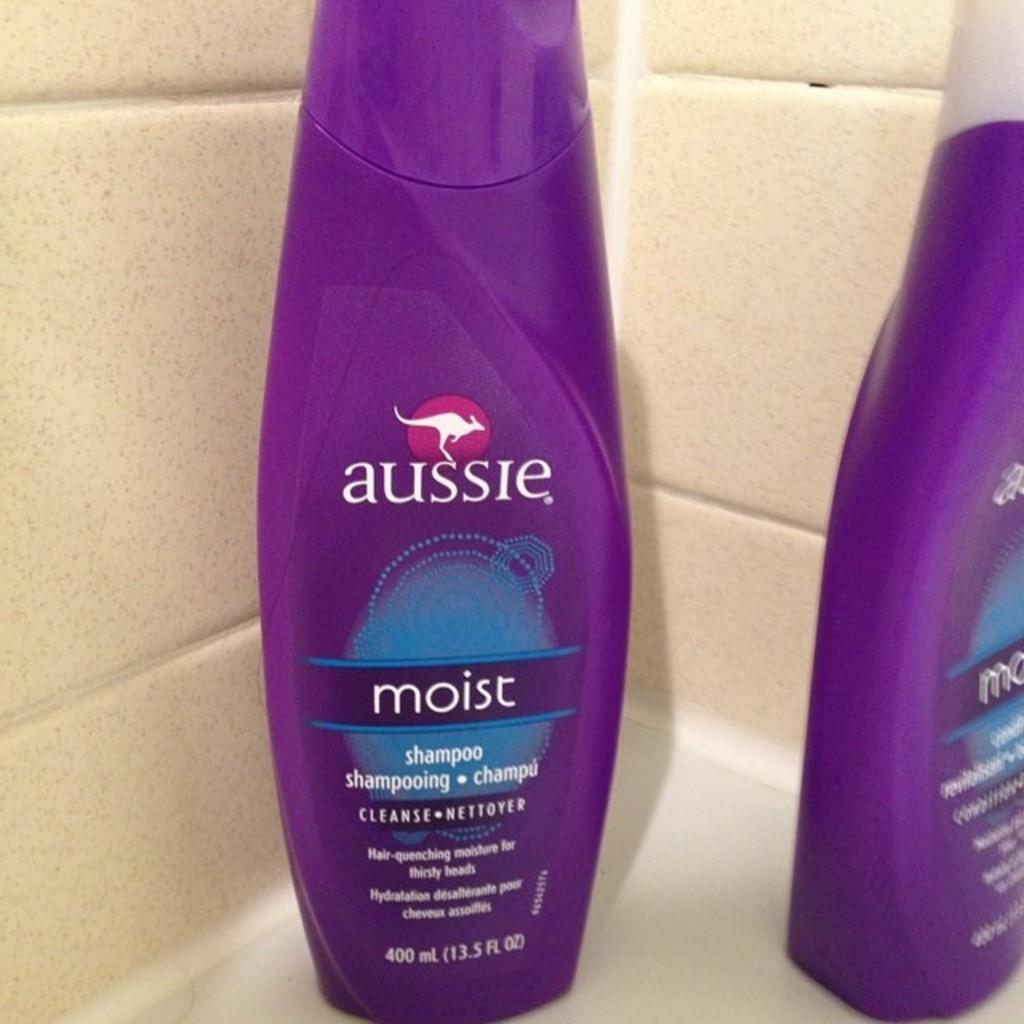Provide a one-sentence caption for the provided image. Two bottles of aussie moist shampoo in a purple bottle. 